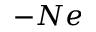Convert formula to latex. <formula><loc_0><loc_0><loc_500><loc_500>- N e</formula> 